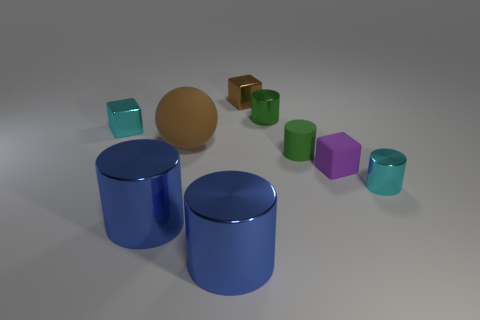Subtract all small rubber cylinders. How many cylinders are left? 4 Subtract all cyan cylinders. How many cylinders are left? 4 Subtract 1 blocks. How many blocks are left? 2 Add 1 matte blocks. How many objects exist? 10 Subtract all balls. How many objects are left? 8 Subtract all gray cylinders. Subtract all brown blocks. How many cylinders are left? 5 Subtract all large green balls. Subtract all small purple matte objects. How many objects are left? 8 Add 5 big blue cylinders. How many big blue cylinders are left? 7 Add 2 large red matte things. How many large red matte things exist? 2 Subtract 0 red cubes. How many objects are left? 9 